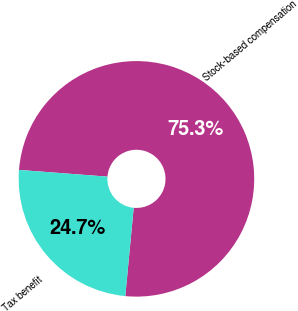Convert chart to OTSL. <chart><loc_0><loc_0><loc_500><loc_500><pie_chart><fcel>Stock-based compensation<fcel>Tax benefit<nl><fcel>75.3%<fcel>24.7%<nl></chart> 